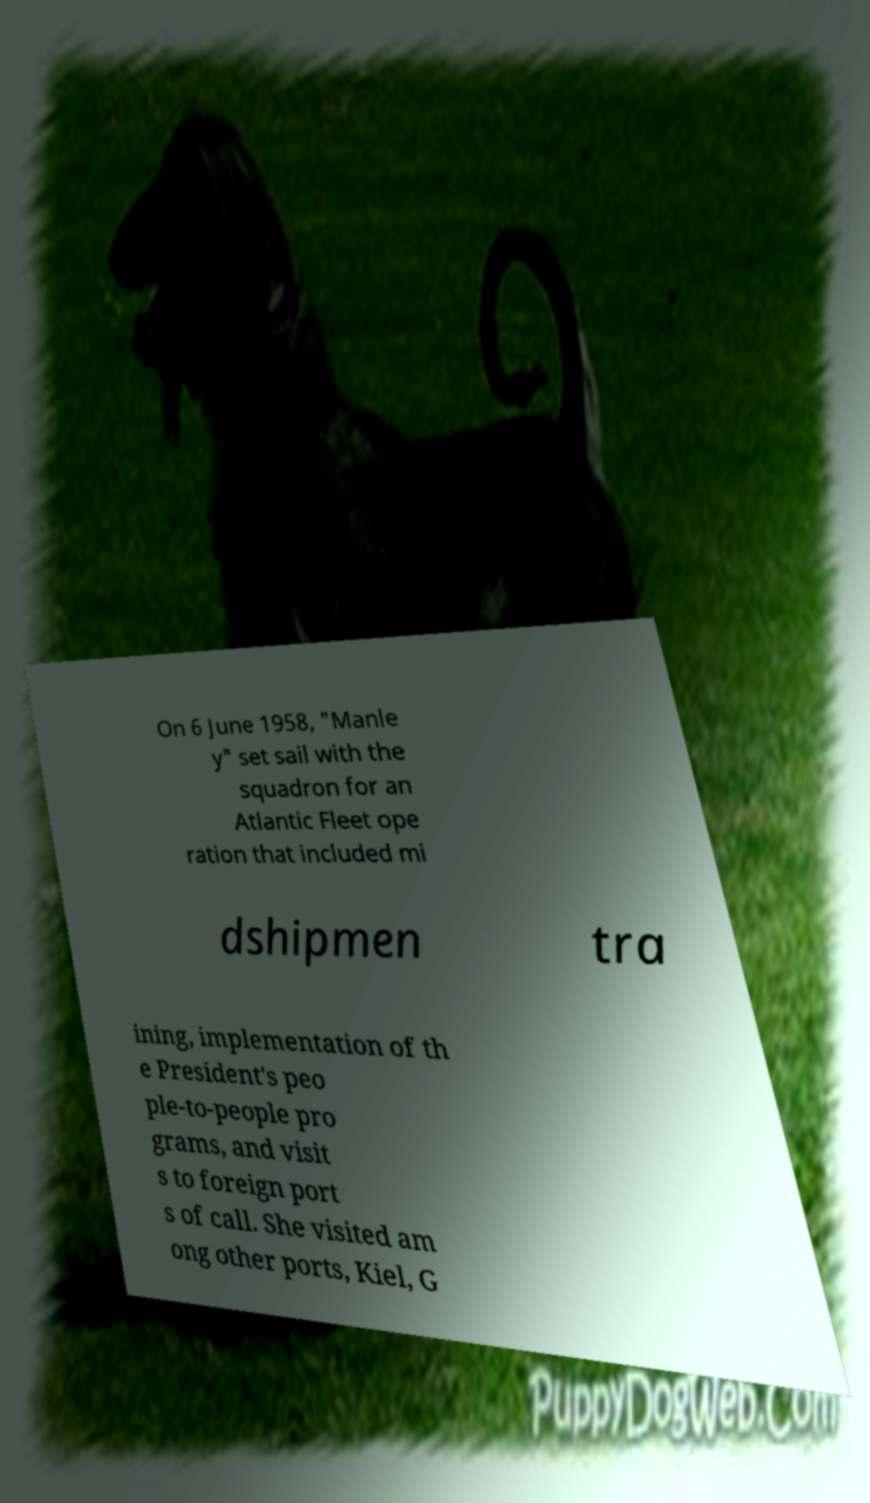Can you read and provide the text displayed in the image?This photo seems to have some interesting text. Can you extract and type it out for me? On 6 June 1958, "Manle y" set sail with the squadron for an Atlantic Fleet ope ration that included mi dshipmen tra ining, implementation of th e President's peo ple-to-people pro grams, and visit s to foreign port s of call. She visited am ong other ports, Kiel, G 